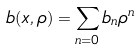Convert formula to latex. <formula><loc_0><loc_0><loc_500><loc_500>b ( x , \rho ) = \sum _ { n = 0 } b _ { n } \rho ^ { n }</formula> 